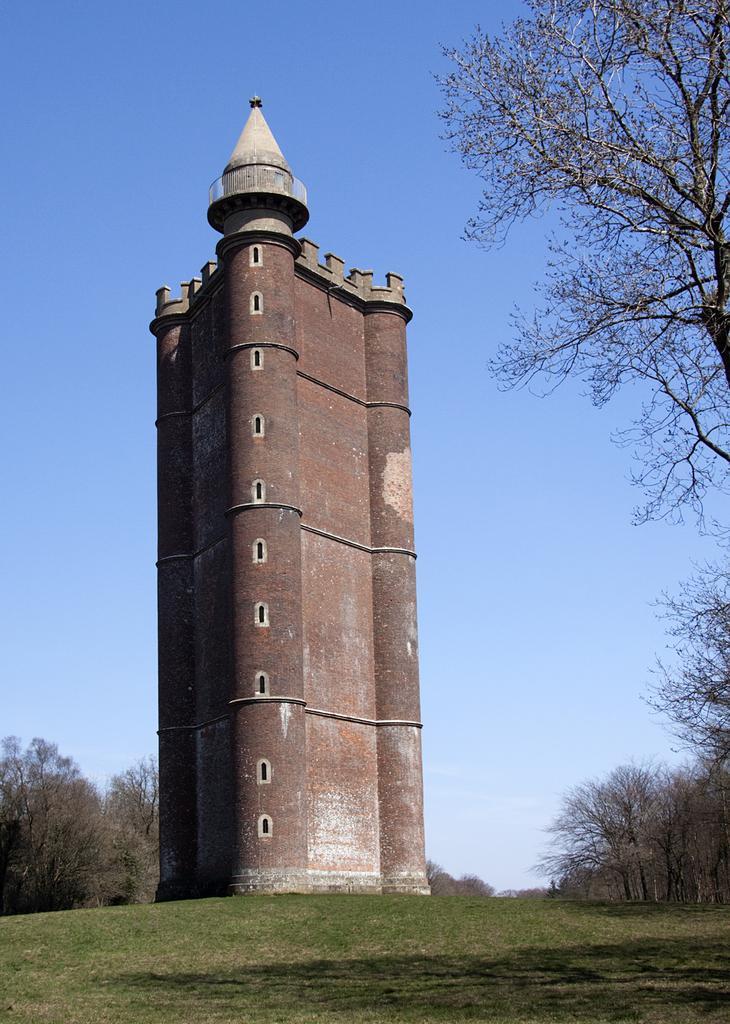How would you summarize this image in a sentence or two? In this picture I can see a building in the middle, there are trees on either side of this image, at the top I can see the sky. 